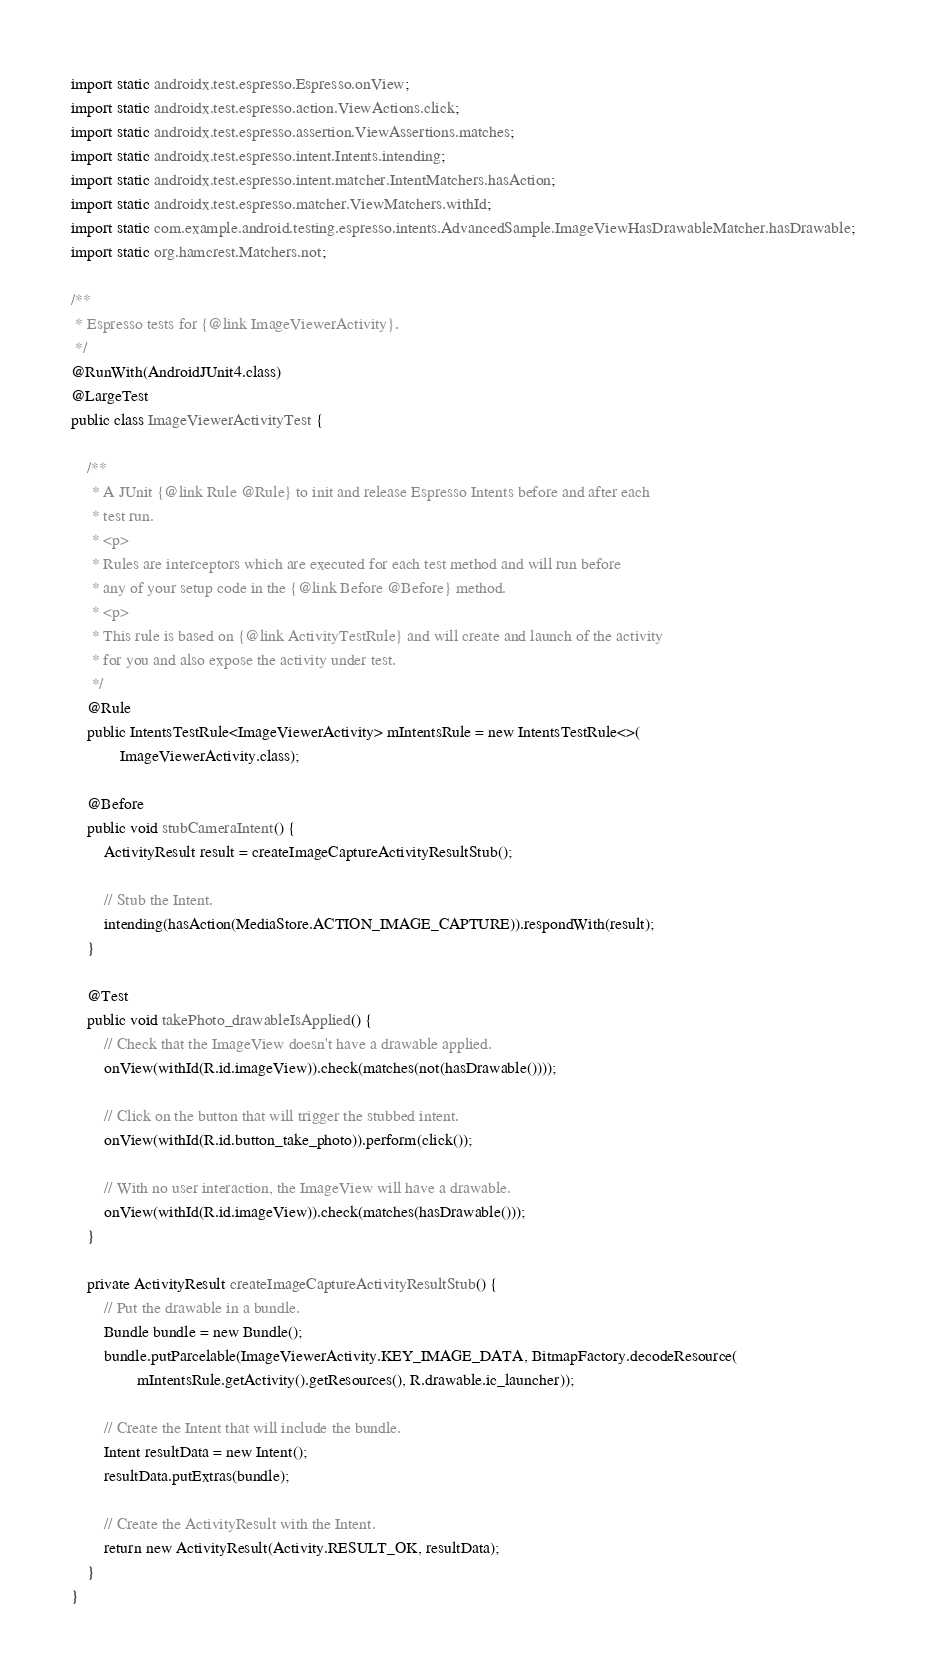Convert code to text. <code><loc_0><loc_0><loc_500><loc_500><_Java_>import static androidx.test.espresso.Espresso.onView;
import static androidx.test.espresso.action.ViewActions.click;
import static androidx.test.espresso.assertion.ViewAssertions.matches;
import static androidx.test.espresso.intent.Intents.intending;
import static androidx.test.espresso.intent.matcher.IntentMatchers.hasAction;
import static androidx.test.espresso.matcher.ViewMatchers.withId;
import static com.example.android.testing.espresso.intents.AdvancedSample.ImageViewHasDrawableMatcher.hasDrawable;
import static org.hamcrest.Matchers.not;

/**
 * Espresso tests for {@link ImageViewerActivity}.
 */
@RunWith(AndroidJUnit4.class)
@LargeTest
public class ImageViewerActivityTest {

    /**
     * A JUnit {@link Rule @Rule} to init and release Espresso Intents before and after each
     * test run.
     * <p>
     * Rules are interceptors which are executed for each test method and will run before
     * any of your setup code in the {@link Before @Before} method.
     * <p>
     * This rule is based on {@link ActivityTestRule} and will create and launch of the activity
     * for you and also expose the activity under test.
     */
    @Rule
    public IntentsTestRule<ImageViewerActivity> mIntentsRule = new IntentsTestRule<>(
            ImageViewerActivity.class);

    @Before
    public void stubCameraIntent() {
        ActivityResult result = createImageCaptureActivityResultStub();

        // Stub the Intent.
        intending(hasAction(MediaStore.ACTION_IMAGE_CAPTURE)).respondWith(result);
    }

    @Test
    public void takePhoto_drawableIsApplied() {
        // Check that the ImageView doesn't have a drawable applied.
        onView(withId(R.id.imageView)).check(matches(not(hasDrawable())));

        // Click on the button that will trigger the stubbed intent.
        onView(withId(R.id.button_take_photo)).perform(click());

        // With no user interaction, the ImageView will have a drawable.
        onView(withId(R.id.imageView)).check(matches(hasDrawable()));
    }

    private ActivityResult createImageCaptureActivityResultStub() {
        // Put the drawable in a bundle.
        Bundle bundle = new Bundle();
        bundle.putParcelable(ImageViewerActivity.KEY_IMAGE_DATA, BitmapFactory.decodeResource(
                mIntentsRule.getActivity().getResources(), R.drawable.ic_launcher));

        // Create the Intent that will include the bundle.
        Intent resultData = new Intent();
        resultData.putExtras(bundle);

        // Create the ActivityResult with the Intent.
        return new ActivityResult(Activity.RESULT_OK, resultData);
    }
}</code> 